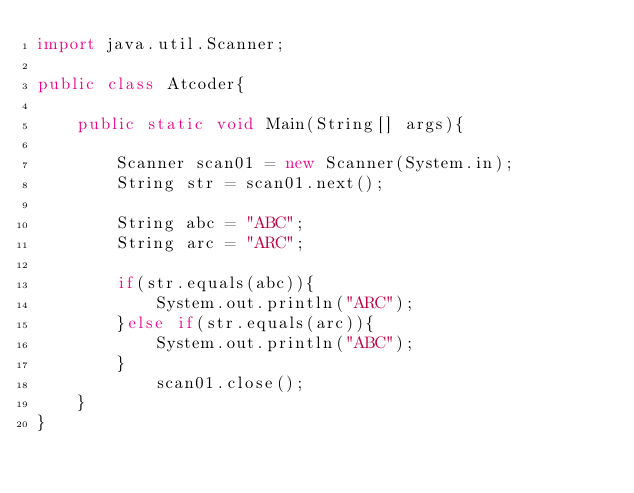Convert code to text. <code><loc_0><loc_0><loc_500><loc_500><_Java_>import java.util.Scanner;

public class Atcoder{

	public static void Main(String[] args){

		Scanner scan01 = new Scanner(System.in);
		String str = scan01.next();

		String abc = "ABC";
		String arc = "ARC";

		if(str.equals(abc)){
			System.out.println("ARC");
		}else if(str.equals(arc)){
			System.out.println("ABC");
		}
			scan01.close();
	}
}</code> 